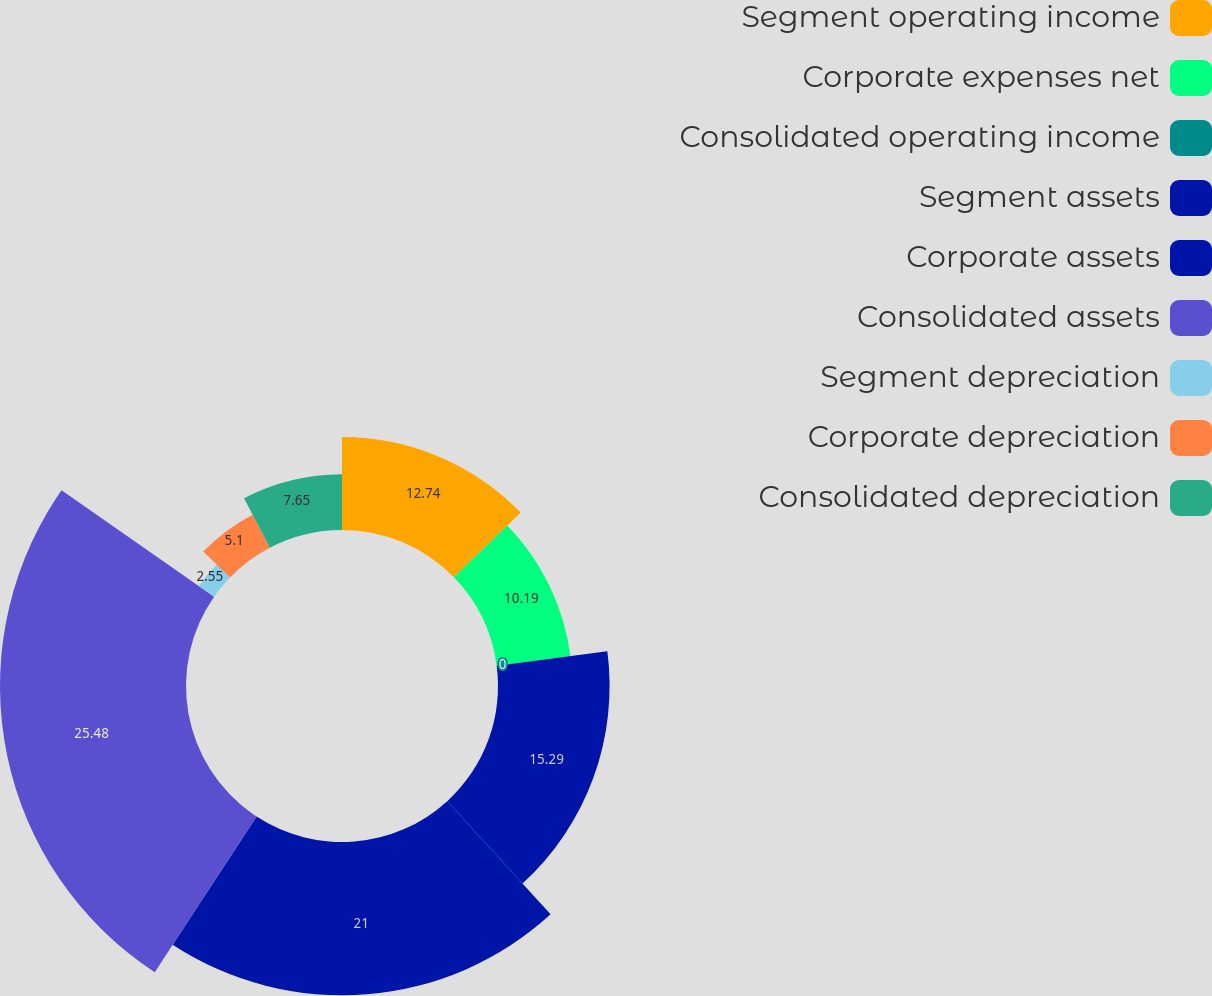Convert chart. <chart><loc_0><loc_0><loc_500><loc_500><pie_chart><fcel>Segment operating income<fcel>Corporate expenses net<fcel>Consolidated operating income<fcel>Segment assets<fcel>Corporate assets<fcel>Consolidated assets<fcel>Segment depreciation<fcel>Corporate depreciation<fcel>Consolidated depreciation<nl><fcel>12.74%<fcel>10.19%<fcel>0.0%<fcel>15.29%<fcel>21.0%<fcel>25.48%<fcel>2.55%<fcel>5.1%<fcel>7.65%<nl></chart> 